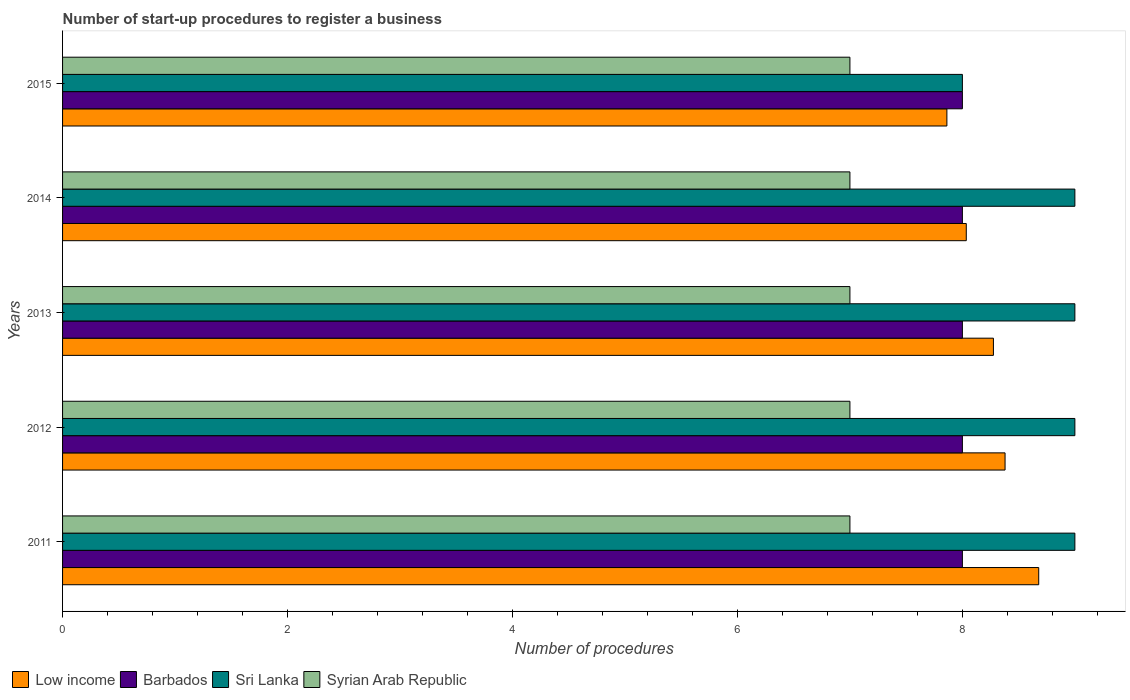How many different coloured bars are there?
Keep it short and to the point. 4. How many groups of bars are there?
Provide a succinct answer. 5. Are the number of bars per tick equal to the number of legend labels?
Offer a terse response. Yes. What is the label of the 5th group of bars from the top?
Give a very brief answer. 2011. What is the number of procedures required to register a business in Sri Lanka in 2011?
Offer a very short reply. 9. Across all years, what is the maximum number of procedures required to register a business in Barbados?
Ensure brevity in your answer.  8. Across all years, what is the minimum number of procedures required to register a business in Syrian Arab Republic?
Provide a succinct answer. 7. In which year was the number of procedures required to register a business in Sri Lanka maximum?
Your answer should be compact. 2011. In which year was the number of procedures required to register a business in Barbados minimum?
Give a very brief answer. 2011. What is the total number of procedures required to register a business in Barbados in the graph?
Provide a succinct answer. 40. What is the difference between the number of procedures required to register a business in Low income in 2014 and the number of procedures required to register a business in Sri Lanka in 2012?
Make the answer very short. -0.97. What is the average number of procedures required to register a business in Syrian Arab Republic per year?
Your response must be concise. 7. In the year 2015, what is the difference between the number of procedures required to register a business in Syrian Arab Republic and number of procedures required to register a business in Sri Lanka?
Offer a terse response. -1. What is the ratio of the number of procedures required to register a business in Barbados in 2011 to that in 2015?
Your answer should be very brief. 1. Is the difference between the number of procedures required to register a business in Syrian Arab Republic in 2011 and 2012 greater than the difference between the number of procedures required to register a business in Sri Lanka in 2011 and 2012?
Ensure brevity in your answer.  No. What is the difference between the highest and the second highest number of procedures required to register a business in Barbados?
Give a very brief answer. 0. What is the difference between the highest and the lowest number of procedures required to register a business in Syrian Arab Republic?
Provide a short and direct response. 0. In how many years, is the number of procedures required to register a business in Sri Lanka greater than the average number of procedures required to register a business in Sri Lanka taken over all years?
Keep it short and to the point. 4. Is it the case that in every year, the sum of the number of procedures required to register a business in Barbados and number of procedures required to register a business in Sri Lanka is greater than the sum of number of procedures required to register a business in Syrian Arab Republic and number of procedures required to register a business in Low income?
Ensure brevity in your answer.  No. What does the 3rd bar from the top in 2012 represents?
Your answer should be very brief. Barbados. What does the 4th bar from the bottom in 2014 represents?
Offer a very short reply. Syrian Arab Republic. Is it the case that in every year, the sum of the number of procedures required to register a business in Sri Lanka and number of procedures required to register a business in Syrian Arab Republic is greater than the number of procedures required to register a business in Barbados?
Ensure brevity in your answer.  Yes. Are all the bars in the graph horizontal?
Keep it short and to the point. Yes. How many years are there in the graph?
Offer a very short reply. 5. What is the difference between two consecutive major ticks on the X-axis?
Ensure brevity in your answer.  2. Does the graph contain any zero values?
Give a very brief answer. No. Does the graph contain grids?
Offer a very short reply. No. How many legend labels are there?
Keep it short and to the point. 4. What is the title of the graph?
Make the answer very short. Number of start-up procedures to register a business. What is the label or title of the X-axis?
Provide a succinct answer. Number of procedures. What is the Number of procedures of Low income in 2011?
Give a very brief answer. 8.68. What is the Number of procedures in Sri Lanka in 2011?
Give a very brief answer. 9. What is the Number of procedures of Low income in 2012?
Your answer should be compact. 8.38. What is the Number of procedures of Syrian Arab Republic in 2012?
Your answer should be very brief. 7. What is the Number of procedures of Low income in 2013?
Offer a terse response. 8.28. What is the Number of procedures in Low income in 2014?
Provide a succinct answer. 8.03. What is the Number of procedures in Barbados in 2014?
Your answer should be compact. 8. What is the Number of procedures in Syrian Arab Republic in 2014?
Provide a succinct answer. 7. What is the Number of procedures in Low income in 2015?
Your answer should be very brief. 7.86. What is the Number of procedures in Barbados in 2015?
Offer a terse response. 8. What is the Number of procedures of Syrian Arab Republic in 2015?
Offer a very short reply. 7. Across all years, what is the maximum Number of procedures of Low income?
Your answer should be compact. 8.68. Across all years, what is the maximum Number of procedures of Barbados?
Provide a short and direct response. 8. Across all years, what is the minimum Number of procedures in Low income?
Your answer should be very brief. 7.86. Across all years, what is the minimum Number of procedures in Barbados?
Offer a very short reply. 8. Across all years, what is the minimum Number of procedures in Sri Lanka?
Provide a short and direct response. 8. Across all years, what is the minimum Number of procedures of Syrian Arab Republic?
Provide a succinct answer. 7. What is the total Number of procedures of Low income in the graph?
Offer a terse response. 41.23. What is the total Number of procedures in Sri Lanka in the graph?
Keep it short and to the point. 44. What is the total Number of procedures of Syrian Arab Republic in the graph?
Your answer should be compact. 35. What is the difference between the Number of procedures in Low income in 2011 and that in 2012?
Make the answer very short. 0.3. What is the difference between the Number of procedures of Sri Lanka in 2011 and that in 2012?
Provide a short and direct response. 0. What is the difference between the Number of procedures in Syrian Arab Republic in 2011 and that in 2012?
Keep it short and to the point. 0. What is the difference between the Number of procedures of Low income in 2011 and that in 2013?
Make the answer very short. 0.4. What is the difference between the Number of procedures of Barbados in 2011 and that in 2013?
Provide a short and direct response. 0. What is the difference between the Number of procedures in Sri Lanka in 2011 and that in 2013?
Provide a succinct answer. 0. What is the difference between the Number of procedures in Syrian Arab Republic in 2011 and that in 2013?
Provide a short and direct response. 0. What is the difference between the Number of procedures of Low income in 2011 and that in 2014?
Your answer should be very brief. 0.64. What is the difference between the Number of procedures of Barbados in 2011 and that in 2014?
Keep it short and to the point. 0. What is the difference between the Number of procedures of Sri Lanka in 2011 and that in 2014?
Your response must be concise. 0. What is the difference between the Number of procedures in Syrian Arab Republic in 2011 and that in 2014?
Your answer should be compact. 0. What is the difference between the Number of procedures in Low income in 2011 and that in 2015?
Offer a very short reply. 0.82. What is the difference between the Number of procedures in Barbados in 2011 and that in 2015?
Make the answer very short. 0. What is the difference between the Number of procedures of Low income in 2012 and that in 2013?
Provide a short and direct response. 0.1. What is the difference between the Number of procedures of Barbados in 2012 and that in 2013?
Provide a succinct answer. 0. What is the difference between the Number of procedures of Low income in 2012 and that in 2014?
Make the answer very short. 0.34. What is the difference between the Number of procedures of Barbados in 2012 and that in 2014?
Make the answer very short. 0. What is the difference between the Number of procedures of Low income in 2012 and that in 2015?
Ensure brevity in your answer.  0.52. What is the difference between the Number of procedures in Barbados in 2012 and that in 2015?
Offer a very short reply. 0. What is the difference between the Number of procedures in Syrian Arab Republic in 2012 and that in 2015?
Provide a short and direct response. 0. What is the difference between the Number of procedures of Low income in 2013 and that in 2014?
Your response must be concise. 0.24. What is the difference between the Number of procedures of Sri Lanka in 2013 and that in 2014?
Your response must be concise. 0. What is the difference between the Number of procedures of Syrian Arab Republic in 2013 and that in 2014?
Offer a terse response. 0. What is the difference between the Number of procedures in Low income in 2013 and that in 2015?
Make the answer very short. 0.41. What is the difference between the Number of procedures of Sri Lanka in 2013 and that in 2015?
Give a very brief answer. 1. What is the difference between the Number of procedures in Low income in 2014 and that in 2015?
Give a very brief answer. 0.17. What is the difference between the Number of procedures of Barbados in 2014 and that in 2015?
Offer a very short reply. 0. What is the difference between the Number of procedures in Sri Lanka in 2014 and that in 2015?
Give a very brief answer. 1. What is the difference between the Number of procedures in Syrian Arab Republic in 2014 and that in 2015?
Make the answer very short. 0. What is the difference between the Number of procedures in Low income in 2011 and the Number of procedures in Barbados in 2012?
Offer a terse response. 0.68. What is the difference between the Number of procedures in Low income in 2011 and the Number of procedures in Sri Lanka in 2012?
Your answer should be compact. -0.32. What is the difference between the Number of procedures of Low income in 2011 and the Number of procedures of Syrian Arab Republic in 2012?
Offer a terse response. 1.68. What is the difference between the Number of procedures in Barbados in 2011 and the Number of procedures in Sri Lanka in 2012?
Ensure brevity in your answer.  -1. What is the difference between the Number of procedures in Barbados in 2011 and the Number of procedures in Syrian Arab Republic in 2012?
Keep it short and to the point. 1. What is the difference between the Number of procedures of Low income in 2011 and the Number of procedures of Barbados in 2013?
Provide a short and direct response. 0.68. What is the difference between the Number of procedures of Low income in 2011 and the Number of procedures of Sri Lanka in 2013?
Your answer should be very brief. -0.32. What is the difference between the Number of procedures in Low income in 2011 and the Number of procedures in Syrian Arab Republic in 2013?
Offer a very short reply. 1.68. What is the difference between the Number of procedures of Barbados in 2011 and the Number of procedures of Sri Lanka in 2013?
Offer a terse response. -1. What is the difference between the Number of procedures in Barbados in 2011 and the Number of procedures in Syrian Arab Republic in 2013?
Your answer should be compact. 1. What is the difference between the Number of procedures in Sri Lanka in 2011 and the Number of procedures in Syrian Arab Republic in 2013?
Provide a short and direct response. 2. What is the difference between the Number of procedures of Low income in 2011 and the Number of procedures of Barbados in 2014?
Your response must be concise. 0.68. What is the difference between the Number of procedures of Low income in 2011 and the Number of procedures of Sri Lanka in 2014?
Offer a very short reply. -0.32. What is the difference between the Number of procedures of Low income in 2011 and the Number of procedures of Syrian Arab Republic in 2014?
Make the answer very short. 1.68. What is the difference between the Number of procedures of Barbados in 2011 and the Number of procedures of Syrian Arab Republic in 2014?
Your response must be concise. 1. What is the difference between the Number of procedures of Sri Lanka in 2011 and the Number of procedures of Syrian Arab Republic in 2014?
Keep it short and to the point. 2. What is the difference between the Number of procedures of Low income in 2011 and the Number of procedures of Barbados in 2015?
Make the answer very short. 0.68. What is the difference between the Number of procedures of Low income in 2011 and the Number of procedures of Sri Lanka in 2015?
Ensure brevity in your answer.  0.68. What is the difference between the Number of procedures of Low income in 2011 and the Number of procedures of Syrian Arab Republic in 2015?
Offer a terse response. 1.68. What is the difference between the Number of procedures of Barbados in 2011 and the Number of procedures of Syrian Arab Republic in 2015?
Provide a succinct answer. 1. What is the difference between the Number of procedures of Low income in 2012 and the Number of procedures of Barbados in 2013?
Provide a succinct answer. 0.38. What is the difference between the Number of procedures in Low income in 2012 and the Number of procedures in Sri Lanka in 2013?
Offer a terse response. -0.62. What is the difference between the Number of procedures of Low income in 2012 and the Number of procedures of Syrian Arab Republic in 2013?
Offer a terse response. 1.38. What is the difference between the Number of procedures in Low income in 2012 and the Number of procedures in Barbados in 2014?
Offer a terse response. 0.38. What is the difference between the Number of procedures of Low income in 2012 and the Number of procedures of Sri Lanka in 2014?
Make the answer very short. -0.62. What is the difference between the Number of procedures of Low income in 2012 and the Number of procedures of Syrian Arab Republic in 2014?
Your answer should be compact. 1.38. What is the difference between the Number of procedures of Barbados in 2012 and the Number of procedures of Sri Lanka in 2014?
Provide a short and direct response. -1. What is the difference between the Number of procedures of Sri Lanka in 2012 and the Number of procedures of Syrian Arab Republic in 2014?
Offer a terse response. 2. What is the difference between the Number of procedures of Low income in 2012 and the Number of procedures of Barbados in 2015?
Give a very brief answer. 0.38. What is the difference between the Number of procedures of Low income in 2012 and the Number of procedures of Sri Lanka in 2015?
Give a very brief answer. 0.38. What is the difference between the Number of procedures in Low income in 2012 and the Number of procedures in Syrian Arab Republic in 2015?
Your response must be concise. 1.38. What is the difference between the Number of procedures of Barbados in 2012 and the Number of procedures of Syrian Arab Republic in 2015?
Give a very brief answer. 1. What is the difference between the Number of procedures of Low income in 2013 and the Number of procedures of Barbados in 2014?
Provide a succinct answer. 0.28. What is the difference between the Number of procedures in Low income in 2013 and the Number of procedures in Sri Lanka in 2014?
Offer a very short reply. -0.72. What is the difference between the Number of procedures in Low income in 2013 and the Number of procedures in Syrian Arab Republic in 2014?
Give a very brief answer. 1.28. What is the difference between the Number of procedures in Barbados in 2013 and the Number of procedures in Sri Lanka in 2014?
Your answer should be very brief. -1. What is the difference between the Number of procedures in Barbados in 2013 and the Number of procedures in Syrian Arab Republic in 2014?
Ensure brevity in your answer.  1. What is the difference between the Number of procedures of Sri Lanka in 2013 and the Number of procedures of Syrian Arab Republic in 2014?
Keep it short and to the point. 2. What is the difference between the Number of procedures in Low income in 2013 and the Number of procedures in Barbados in 2015?
Keep it short and to the point. 0.28. What is the difference between the Number of procedures of Low income in 2013 and the Number of procedures of Sri Lanka in 2015?
Provide a short and direct response. 0.28. What is the difference between the Number of procedures in Low income in 2013 and the Number of procedures in Syrian Arab Republic in 2015?
Your answer should be compact. 1.28. What is the difference between the Number of procedures in Barbados in 2013 and the Number of procedures in Sri Lanka in 2015?
Give a very brief answer. 0. What is the difference between the Number of procedures in Sri Lanka in 2013 and the Number of procedures in Syrian Arab Republic in 2015?
Your answer should be compact. 2. What is the difference between the Number of procedures in Low income in 2014 and the Number of procedures in Barbados in 2015?
Your answer should be very brief. 0.03. What is the difference between the Number of procedures in Low income in 2014 and the Number of procedures in Sri Lanka in 2015?
Your answer should be compact. 0.03. What is the difference between the Number of procedures in Low income in 2014 and the Number of procedures in Syrian Arab Republic in 2015?
Your answer should be compact. 1.03. What is the difference between the Number of procedures of Sri Lanka in 2014 and the Number of procedures of Syrian Arab Republic in 2015?
Provide a succinct answer. 2. What is the average Number of procedures of Low income per year?
Make the answer very short. 8.25. In the year 2011, what is the difference between the Number of procedures of Low income and Number of procedures of Barbados?
Provide a short and direct response. 0.68. In the year 2011, what is the difference between the Number of procedures in Low income and Number of procedures in Sri Lanka?
Provide a short and direct response. -0.32. In the year 2011, what is the difference between the Number of procedures of Low income and Number of procedures of Syrian Arab Republic?
Give a very brief answer. 1.68. In the year 2011, what is the difference between the Number of procedures of Sri Lanka and Number of procedures of Syrian Arab Republic?
Provide a succinct answer. 2. In the year 2012, what is the difference between the Number of procedures of Low income and Number of procedures of Barbados?
Your answer should be very brief. 0.38. In the year 2012, what is the difference between the Number of procedures in Low income and Number of procedures in Sri Lanka?
Provide a short and direct response. -0.62. In the year 2012, what is the difference between the Number of procedures of Low income and Number of procedures of Syrian Arab Republic?
Provide a short and direct response. 1.38. In the year 2013, what is the difference between the Number of procedures of Low income and Number of procedures of Barbados?
Keep it short and to the point. 0.28. In the year 2013, what is the difference between the Number of procedures in Low income and Number of procedures in Sri Lanka?
Keep it short and to the point. -0.72. In the year 2013, what is the difference between the Number of procedures in Low income and Number of procedures in Syrian Arab Republic?
Your answer should be very brief. 1.28. In the year 2013, what is the difference between the Number of procedures of Barbados and Number of procedures of Sri Lanka?
Your answer should be compact. -1. In the year 2013, what is the difference between the Number of procedures in Sri Lanka and Number of procedures in Syrian Arab Republic?
Provide a short and direct response. 2. In the year 2014, what is the difference between the Number of procedures in Low income and Number of procedures in Barbados?
Offer a terse response. 0.03. In the year 2014, what is the difference between the Number of procedures of Low income and Number of procedures of Sri Lanka?
Provide a short and direct response. -0.97. In the year 2014, what is the difference between the Number of procedures in Low income and Number of procedures in Syrian Arab Republic?
Give a very brief answer. 1.03. In the year 2014, what is the difference between the Number of procedures of Barbados and Number of procedures of Sri Lanka?
Offer a very short reply. -1. In the year 2014, what is the difference between the Number of procedures of Sri Lanka and Number of procedures of Syrian Arab Republic?
Ensure brevity in your answer.  2. In the year 2015, what is the difference between the Number of procedures in Low income and Number of procedures in Barbados?
Ensure brevity in your answer.  -0.14. In the year 2015, what is the difference between the Number of procedures in Low income and Number of procedures in Sri Lanka?
Provide a short and direct response. -0.14. In the year 2015, what is the difference between the Number of procedures in Low income and Number of procedures in Syrian Arab Republic?
Your response must be concise. 0.86. What is the ratio of the Number of procedures in Low income in 2011 to that in 2012?
Offer a very short reply. 1.04. What is the ratio of the Number of procedures of Low income in 2011 to that in 2013?
Provide a succinct answer. 1.05. What is the ratio of the Number of procedures of Barbados in 2011 to that in 2013?
Give a very brief answer. 1. What is the ratio of the Number of procedures of Low income in 2011 to that in 2014?
Make the answer very short. 1.08. What is the ratio of the Number of procedures in Barbados in 2011 to that in 2014?
Ensure brevity in your answer.  1. What is the ratio of the Number of procedures in Syrian Arab Republic in 2011 to that in 2014?
Your answer should be very brief. 1. What is the ratio of the Number of procedures of Low income in 2011 to that in 2015?
Provide a succinct answer. 1.1. What is the ratio of the Number of procedures of Barbados in 2011 to that in 2015?
Keep it short and to the point. 1. What is the ratio of the Number of procedures of Sri Lanka in 2011 to that in 2015?
Make the answer very short. 1.12. What is the ratio of the Number of procedures of Syrian Arab Republic in 2011 to that in 2015?
Ensure brevity in your answer.  1. What is the ratio of the Number of procedures in Low income in 2012 to that in 2013?
Your response must be concise. 1.01. What is the ratio of the Number of procedures in Barbados in 2012 to that in 2013?
Make the answer very short. 1. What is the ratio of the Number of procedures in Sri Lanka in 2012 to that in 2013?
Give a very brief answer. 1. What is the ratio of the Number of procedures of Syrian Arab Republic in 2012 to that in 2013?
Provide a succinct answer. 1. What is the ratio of the Number of procedures of Low income in 2012 to that in 2014?
Provide a short and direct response. 1.04. What is the ratio of the Number of procedures in Barbados in 2012 to that in 2014?
Ensure brevity in your answer.  1. What is the ratio of the Number of procedures in Syrian Arab Republic in 2012 to that in 2014?
Ensure brevity in your answer.  1. What is the ratio of the Number of procedures in Low income in 2012 to that in 2015?
Make the answer very short. 1.07. What is the ratio of the Number of procedures of Sri Lanka in 2012 to that in 2015?
Your answer should be very brief. 1.12. What is the ratio of the Number of procedures of Low income in 2013 to that in 2014?
Provide a succinct answer. 1.03. What is the ratio of the Number of procedures of Syrian Arab Republic in 2013 to that in 2014?
Offer a terse response. 1. What is the ratio of the Number of procedures of Low income in 2013 to that in 2015?
Provide a short and direct response. 1.05. What is the ratio of the Number of procedures of Barbados in 2013 to that in 2015?
Give a very brief answer. 1. What is the ratio of the Number of procedures of Sri Lanka in 2013 to that in 2015?
Give a very brief answer. 1.12. What is the ratio of the Number of procedures of Syrian Arab Republic in 2013 to that in 2015?
Offer a terse response. 1. What is the ratio of the Number of procedures in Low income in 2014 to that in 2015?
Give a very brief answer. 1.02. What is the ratio of the Number of procedures in Sri Lanka in 2014 to that in 2015?
Offer a very short reply. 1.12. What is the difference between the highest and the second highest Number of procedures in Low income?
Offer a terse response. 0.3. What is the difference between the highest and the second highest Number of procedures in Barbados?
Give a very brief answer. 0. What is the difference between the highest and the lowest Number of procedures of Low income?
Make the answer very short. 0.82. What is the difference between the highest and the lowest Number of procedures in Sri Lanka?
Give a very brief answer. 1. What is the difference between the highest and the lowest Number of procedures in Syrian Arab Republic?
Offer a very short reply. 0. 